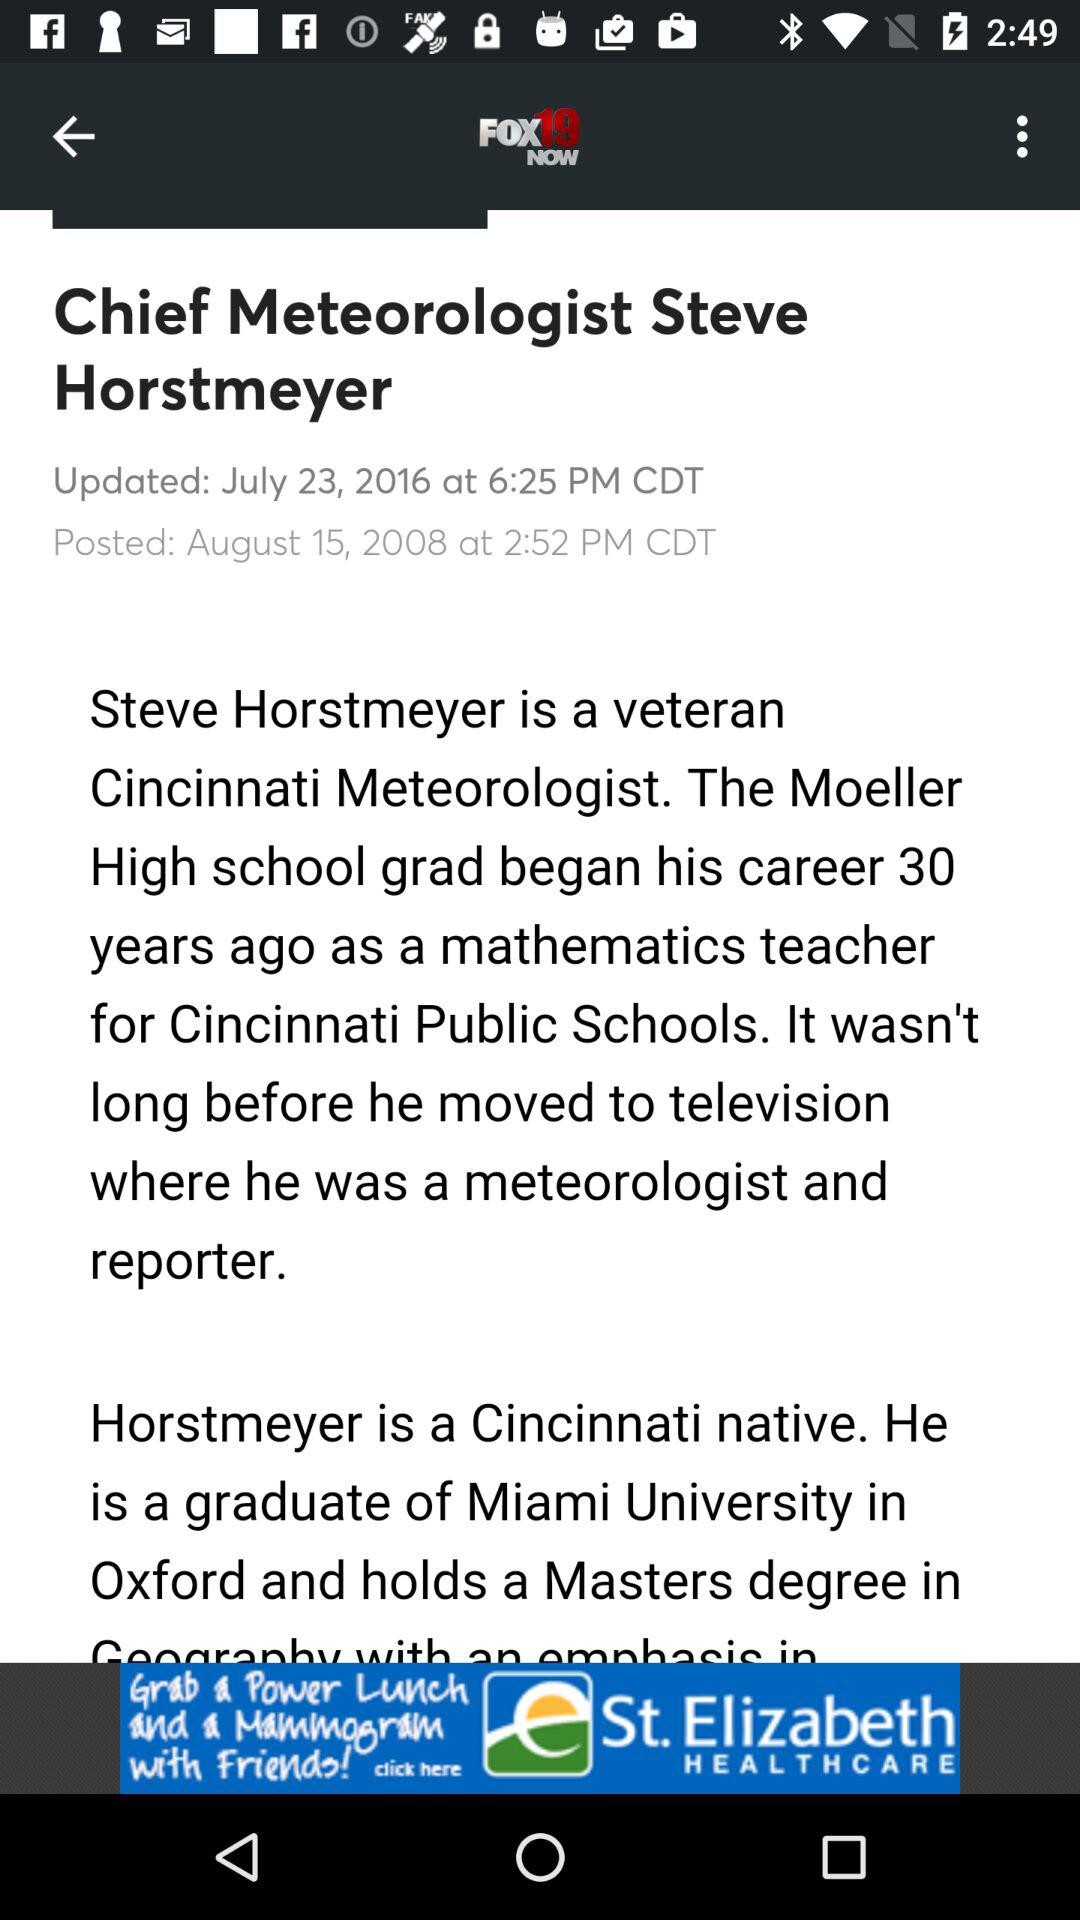What is the application name? The application name is "FOX19 Now". 